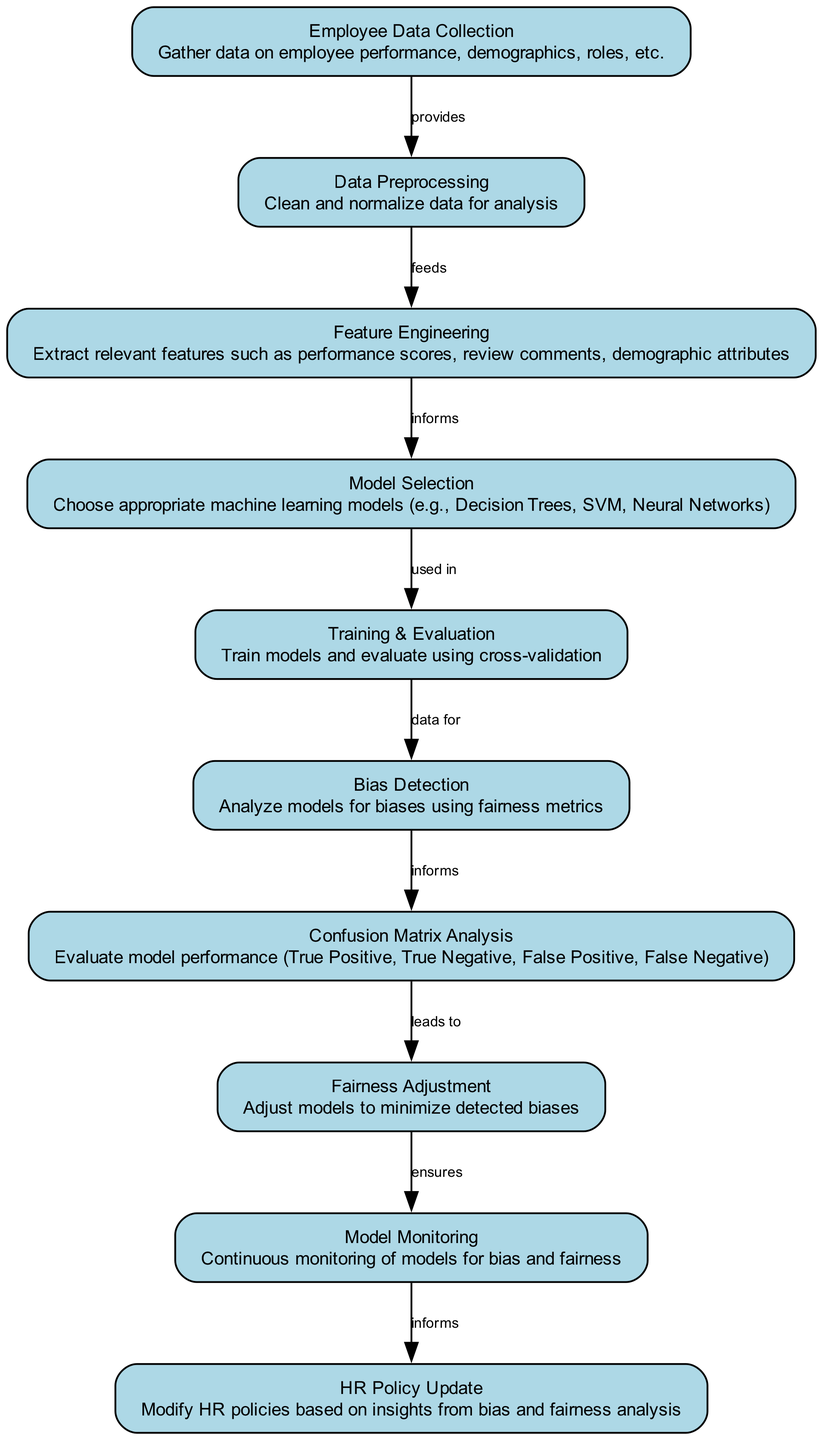What is the first node in the diagram? The first node is labeled "Employee Data Collection," which indicates that the process starts with gathering data on employee performance and demographics.
Answer: Employee Data Collection How many nodes are present in the diagram? By counting the individual elements labeled in the diagram, we see there are a total of ten distinct nodes listed.
Answer: 10 What is the last step before the HR Policy Update? The last step before "HR Policy Update" is "Model Monitoring," which informs the policy update process by continuously checking for bias and fairness.
Answer: Model Monitoring What node provides data for the Bias Detection step? The node that provides data for "Bias Detection" is "Training & Evaluation," as it informs the analysis of models for biases using fairness metrics.
Answer: Training & Evaluation Which node leads to Fairness Adjustment? The node "Confusion Matrix Analysis" leads to "Fairness Adjustment," as it evaluates model performance and allows for adjustments to minimize biases.
Answer: Confusion Matrix Analysis What type of machine learning models can be selected in the Model Selection step? The "Model Selection" node mentions that appropriate machine learning models like Decision Trees, SVM, and Neural Networks can be chosen in this step.
Answer: Decision Trees, SVM, Neural Networks What relationship exists between Feature Engineering and Model Selection? The relationship is that "Feature Engineering" informs "Model Selection," meaning the extracted features are used to inform the choice of models.
Answer: informs Which nodes are directly connected to the Bias Detection node? The nodes directly connected to "Bias Detection" are "Training & Evaluation," which feeds data into it, and "Confusion Matrix Analysis," which informs it about potential biases.
Answer: Training & Evaluation, Confusion Matrix Analysis What is the purpose of the Confusion Matrix Analysis? The purpose of "Confusion Matrix Analysis" is to evaluate model performance by assessing True Positive, True Negative, False Positive, and False Negative outcomes.
Answer: Evaluate model performance What does the Model Monitoring step ensure? The "Model Monitoring" step ensures continuous oversight of models for bias and fairness, aiming to sustain equitable practices in performance evaluations.
Answer: Continuous monitoring of models for bias and fairness 